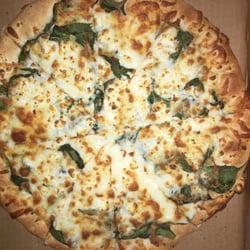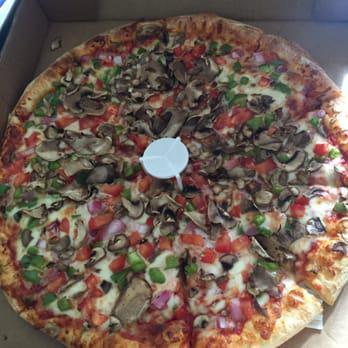The first image is the image on the left, the second image is the image on the right. Given the left and right images, does the statement "There are two complete pizzas." hold true? Answer yes or no. Yes. The first image is the image on the left, the second image is the image on the right. Analyze the images presented: Is the assertion "One image shows a pizza in an open box and includes at least two condiment containers in the image." valid? Answer yes or no. No. 